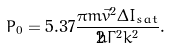<formula> <loc_0><loc_0><loc_500><loc_500>P _ { 0 } = 5 . 3 7 \frac { \pi m \vec { v } ^ { 2 } \Delta I _ { s a t } } { 2 \hbar { \Gamma } ^ { 2 } k ^ { 2 } } .</formula> 